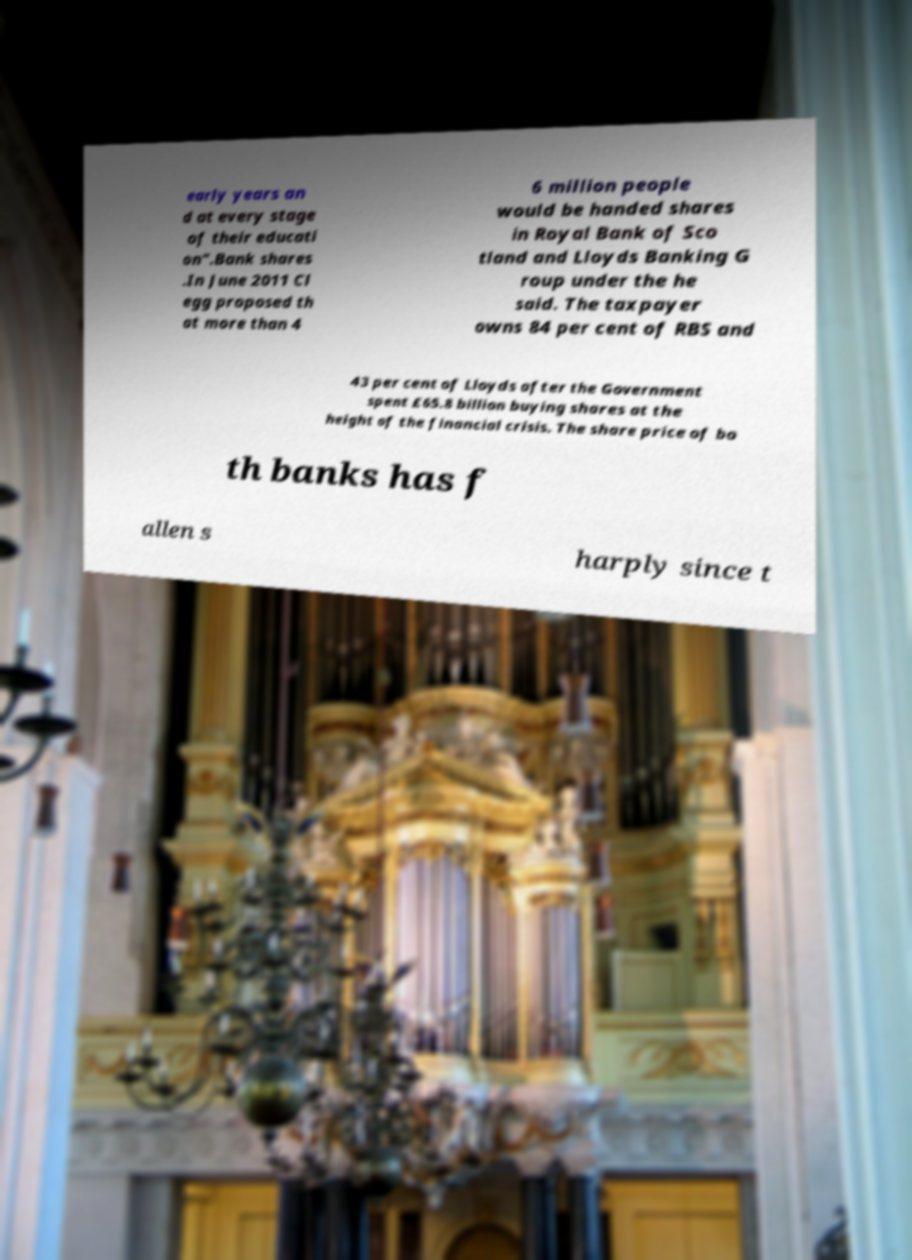There's text embedded in this image that I need extracted. Can you transcribe it verbatim? early years an d at every stage of their educati on".Bank shares .In June 2011 Cl egg proposed th at more than 4 6 million people would be handed shares in Royal Bank of Sco tland and Lloyds Banking G roup under the he said. The taxpayer owns 84 per cent of RBS and 43 per cent of Lloyds after the Government spent £65.8 billion buying shares at the height of the financial crisis. The share price of bo th banks has f allen s harply since t 